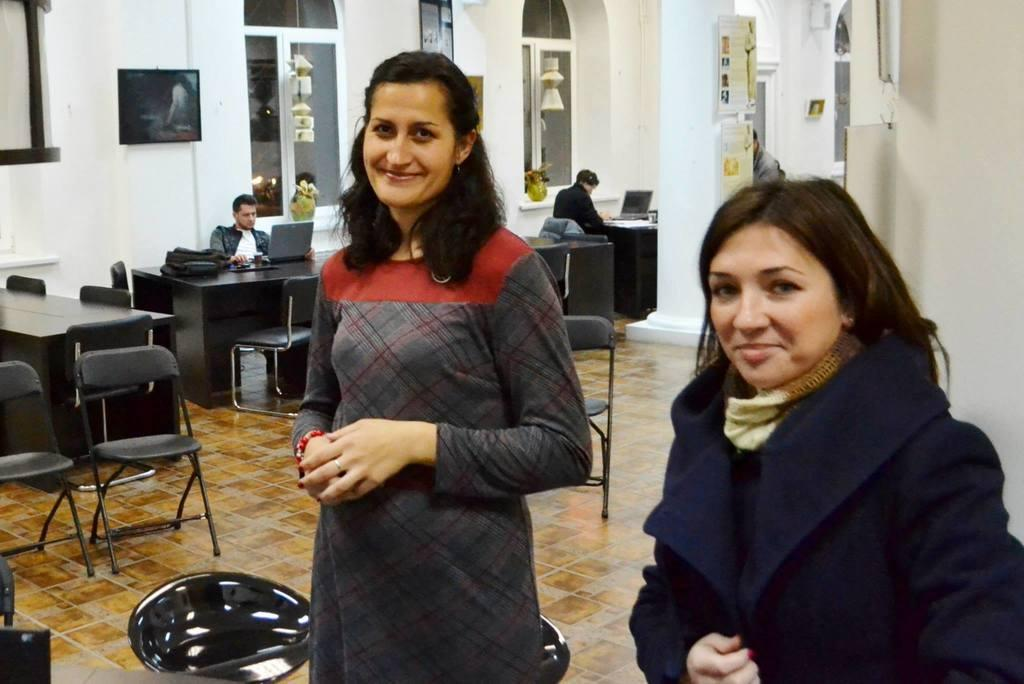What color is the wall in the image? The wall in the image is white. What can be seen hanging on the wall? There is a photo frame in the image. What type of furniture is present in the image? There are chairs and tables in the image. Are there any people in the image? Yes, there are people in the image. What items can be seen on the tables in the image? There is a bag and a laptop on a table in the image. What type of seed is being planted by the government in the image? There is no mention of seeds or the government in the image. What form is the laptop taking in the image? The laptop is not taking any specific form in the image; it is a standard laptop on a table. 